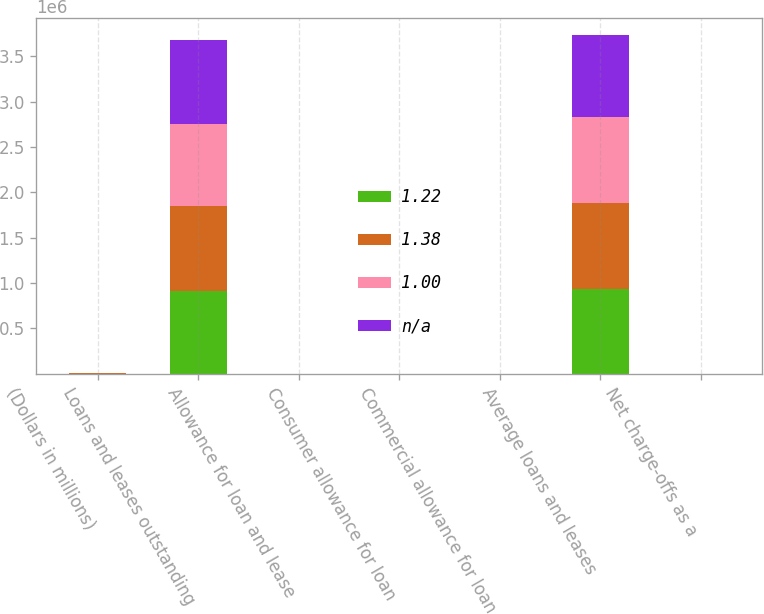Convert chart. <chart><loc_0><loc_0><loc_500><loc_500><stacked_bar_chart><ecel><fcel>(Dollars in millions)<fcel>Loans and leases outstanding<fcel>Allowance for loan and lease<fcel>Consumer allowance for loan<fcel>Commercial allowance for loan<fcel>Average loans and leases<fcel>Net charge-offs as a<nl><fcel>1.22<fcel>2011<fcel>917396<fcel>135<fcel>4.88<fcel>1.33<fcel>929661<fcel>2.24<nl><fcel>1.38<fcel>2010<fcel>937119<fcel>136<fcel>5.4<fcel>2.44<fcel>954278<fcel>3.6<nl><fcel>1<fcel>2009<fcel>895192<fcel>111<fcel>4.81<fcel>2.96<fcel>941862<fcel>3.58<nl><fcel>nan<fcel>2008<fcel>926033<fcel>141<fcel>2.83<fcel>1.9<fcel>905944<fcel>1.79<nl></chart> 